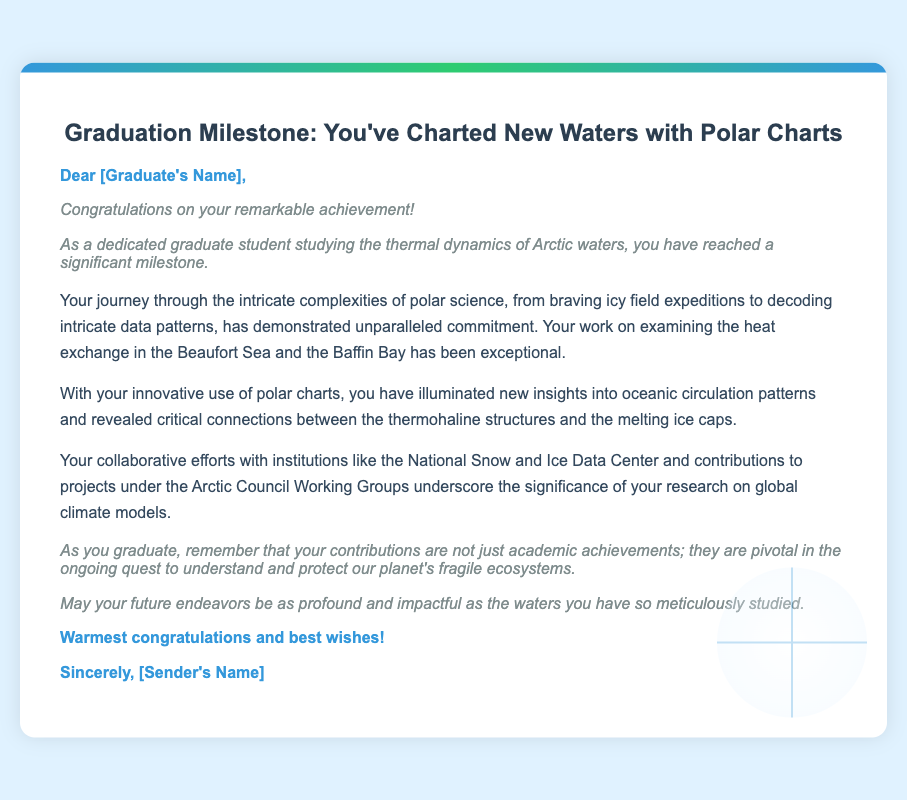what is the title of the card? The title of the card is presented at the top of the document.
Answer: Graduation Milestone: You've Charted New Waters with Polar Charts who is the card addressed to? The greeting specifically mentions "[Graduate's Name]," indicating who the card is for.
Answer: [Graduate's Name] what field of study is highlighted in the card? The card mentions the graduate’s focus on studying specific environmental science related topics.
Answer: thermal dynamics of Arctic waters which seas are referenced in the document? The body of the text specifically names two regions relevant to the graduate's studies.
Answer: Beaufort Sea and Baffin Bay who collaborates with the graduate according to the card? The card references a specific organization that is mentioned as a partner in research.
Answer: National Snow and Ice Data Center what is emphasized as a significant outcome of the graduate's work? The document summarizes the impact of the graduate's research contributions to broader environmental concerns.
Answer: understanding and protecting our planet's fragile ecosystems what is the tone of the closing statement? The closing statement reflects the sentiment conveyed in the conclusion, highlighting the card's overall sentiment.
Answer: warmest congratulations and best wishes who is the card signed by? The signature section of the document indicates who is sending the card.
Answer: [Sender's Name] 